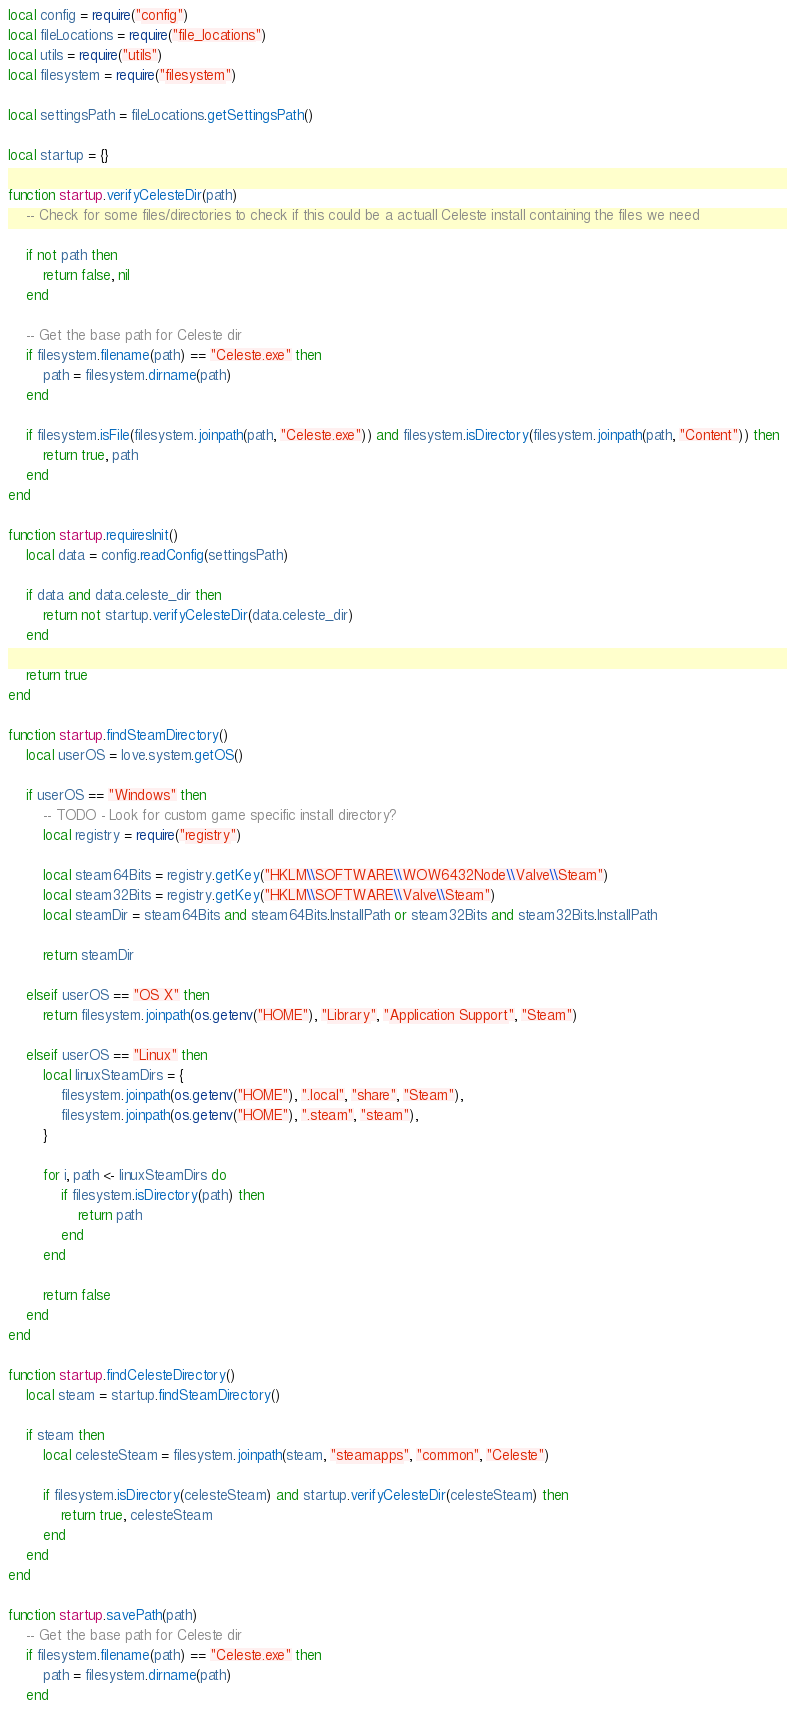Convert code to text. <code><loc_0><loc_0><loc_500><loc_500><_Lua_>local config = require("config")
local fileLocations = require("file_locations")
local utils = require("utils")
local filesystem = require("filesystem")

local settingsPath = fileLocations.getSettingsPath()

local startup = {}

function startup.verifyCelesteDir(path)
    -- Check for some files/directories to check if this could be a actuall Celeste install containing the files we need

    if not path then
        return false, nil
    end

    -- Get the base path for Celeste dir
    if filesystem.filename(path) == "Celeste.exe" then
        path = filesystem.dirname(path)
    end

    if filesystem.isFile(filesystem.joinpath(path, "Celeste.exe")) and filesystem.isDirectory(filesystem.joinpath(path, "Content")) then
        return true, path
    end
end

function startup.requiresInit()
    local data = config.readConfig(settingsPath)

    if data and data.celeste_dir then
        return not startup.verifyCelesteDir(data.celeste_dir)
    end

    return true
end

function startup.findSteamDirectory()
    local userOS = love.system.getOS()

    if userOS == "Windows" then
        -- TODO - Look for custom game specific install directory?
        local registry = require("registry")

        local steam64Bits = registry.getKey("HKLM\\SOFTWARE\\WOW6432Node\\Valve\\Steam")
        local steam32Bits = registry.getKey("HKLM\\SOFTWARE\\Valve\\Steam")
        local steamDir = steam64Bits and steam64Bits.InstallPath or steam32Bits and steam32Bits.InstallPath

        return steamDir

    elseif userOS == "OS X" then
        return filesystem.joinpath(os.getenv("HOME"), "Library", "Application Support", "Steam")

    elseif userOS == "Linux" then
        local linuxSteamDirs = {
            filesystem.joinpath(os.getenv("HOME"), ".local", "share", "Steam"),
            filesystem.joinpath(os.getenv("HOME"), ".steam", "steam"),
        }

        for i, path <- linuxSteamDirs do
            if filesystem.isDirectory(path) then
                return path
            end
        end

        return false
    end
end

function startup.findCelesteDirectory()
    local steam = startup.findSteamDirectory()

    if steam then
        local celesteSteam = filesystem.joinpath(steam, "steamapps", "common", "Celeste")

        if filesystem.isDirectory(celesteSteam) and startup.verifyCelesteDir(celesteSteam) then
            return true, celesteSteam
        end
    end
end

function startup.savePath(path)
    -- Get the base path for Celeste dir
    if filesystem.filename(path) == "Celeste.exe" then
        path = filesystem.dirname(path)
    end
</code> 